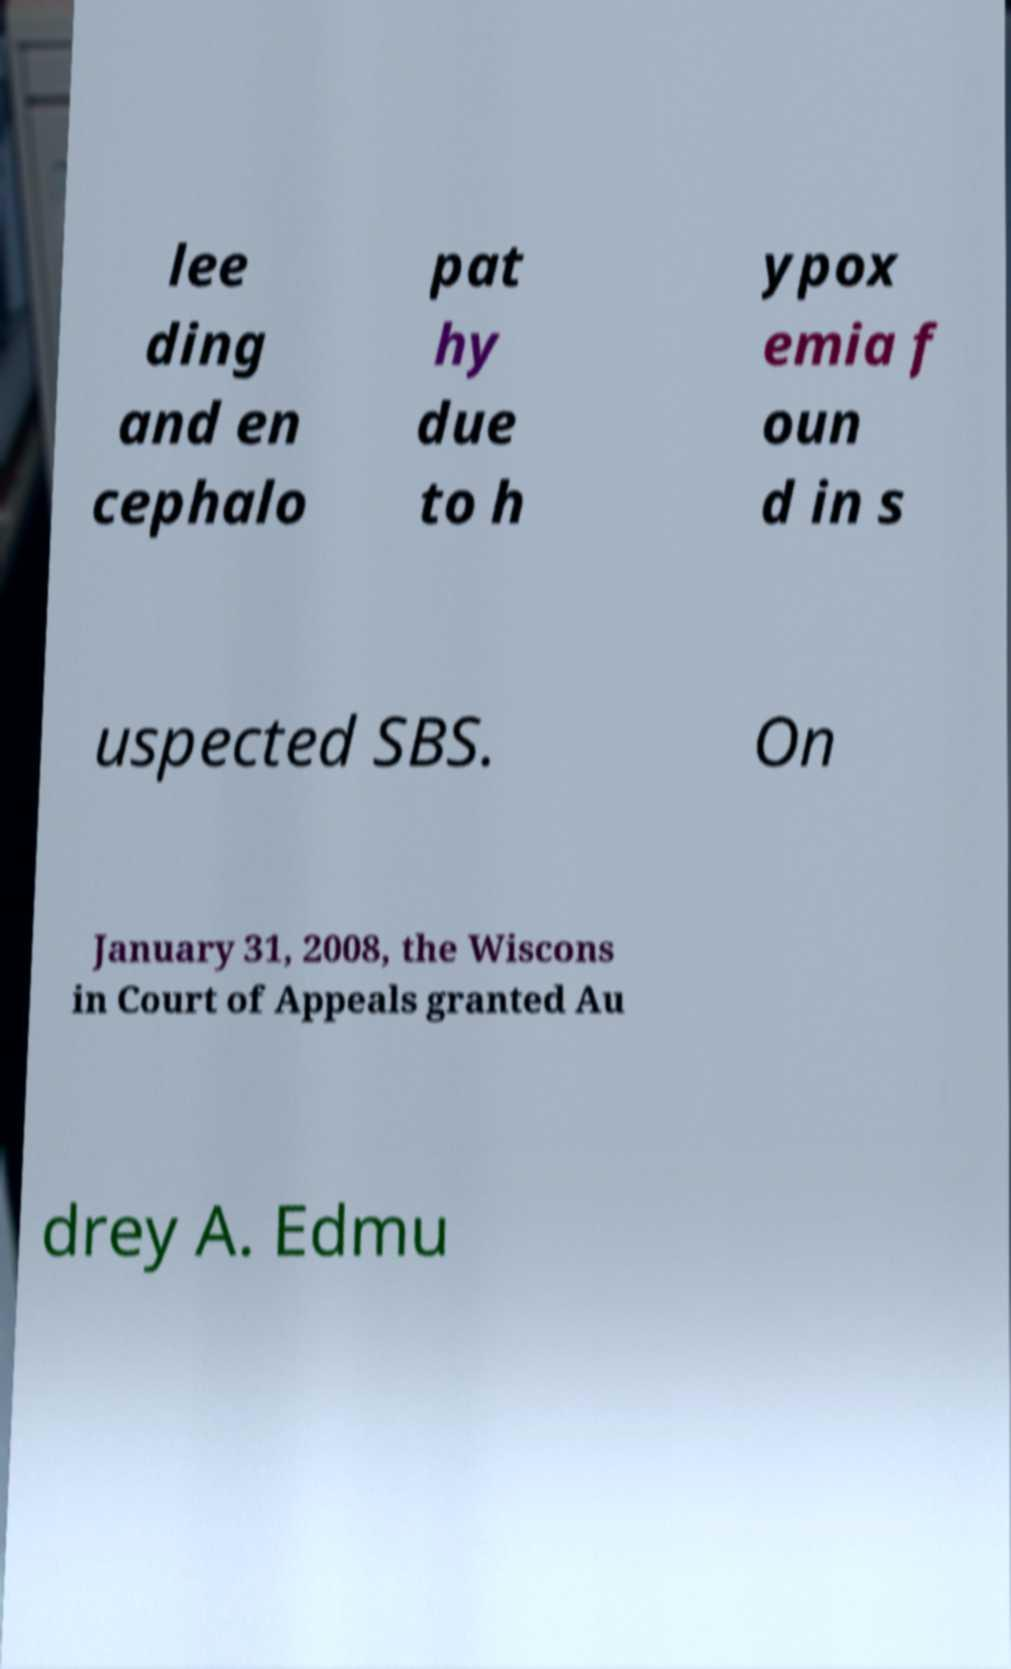What messages or text are displayed in this image? I need them in a readable, typed format. lee ding and en cephalo pat hy due to h ypox emia f oun d in s uspected SBS. On January 31, 2008, the Wiscons in Court of Appeals granted Au drey A. Edmu 